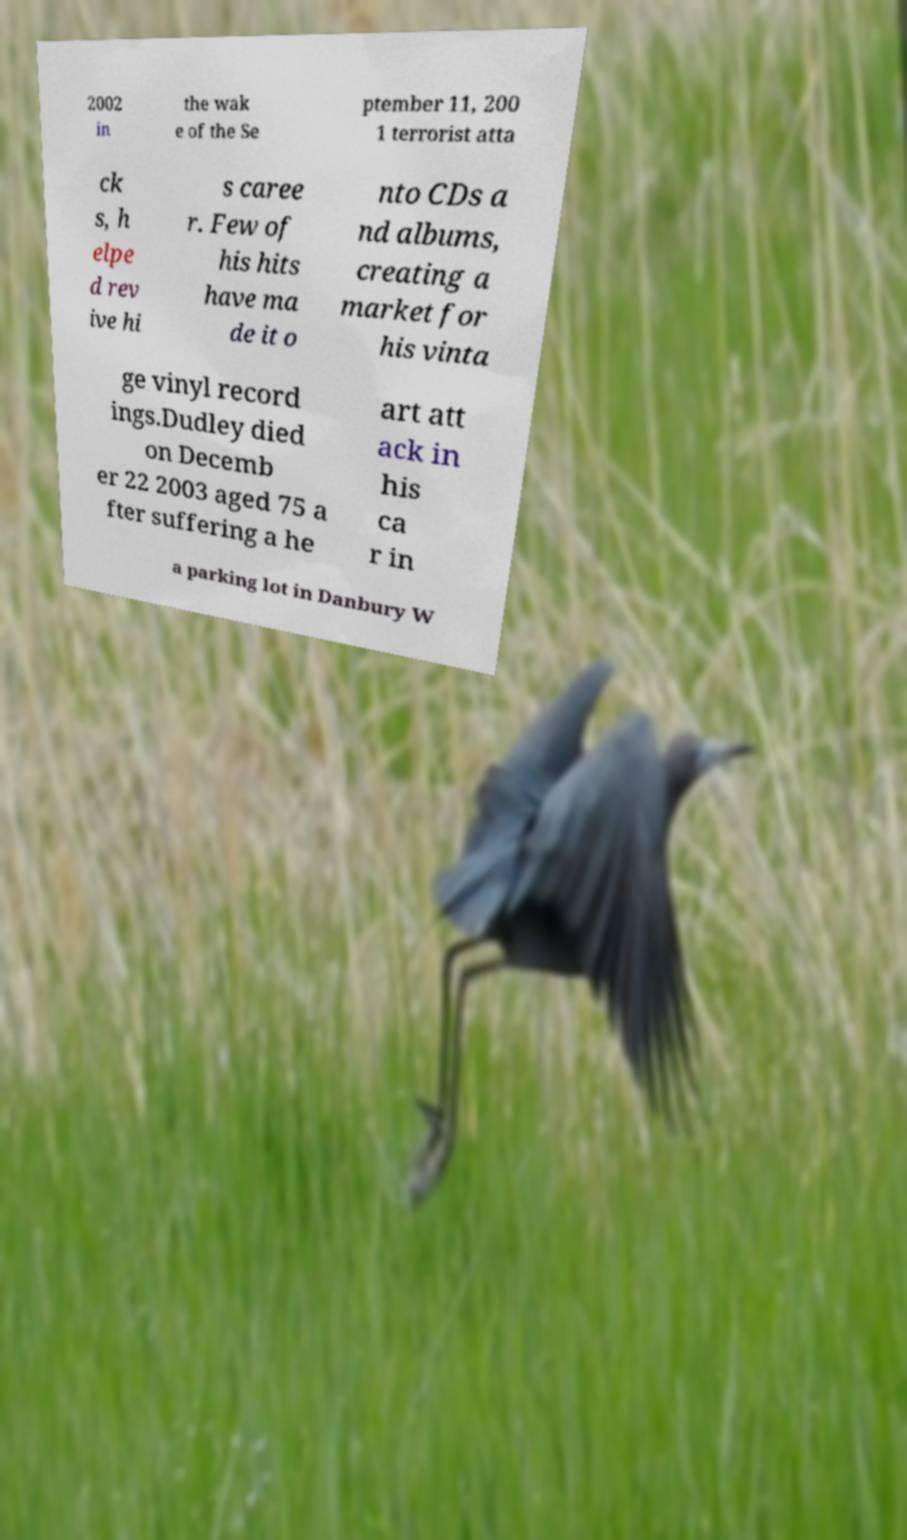Can you accurately transcribe the text from the provided image for me? 2002 in the wak e of the Se ptember 11, 200 1 terrorist atta ck s, h elpe d rev ive hi s caree r. Few of his hits have ma de it o nto CDs a nd albums, creating a market for his vinta ge vinyl record ings.Dudley died on Decemb er 22 2003 aged 75 a fter suffering a he art att ack in his ca r in a parking lot in Danbury W 